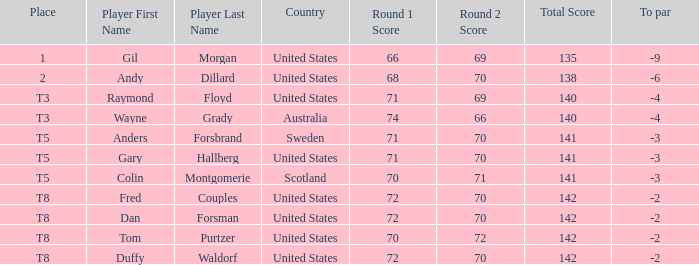What is the to par of the player with a total of 70-71=141? -3.0. 